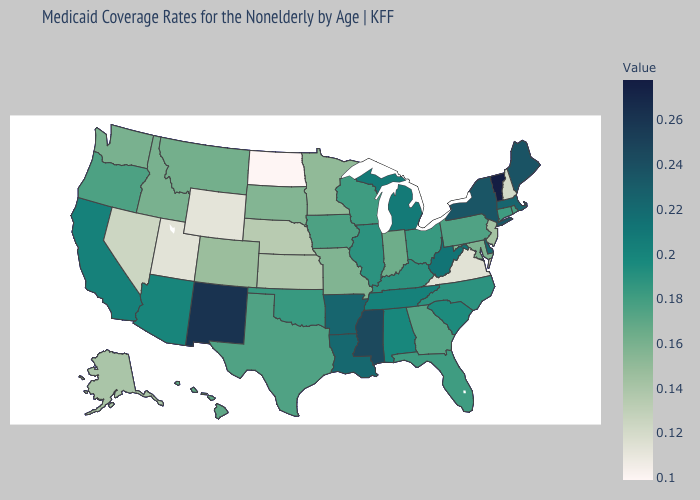Does North Dakota have the lowest value in the USA?
Be succinct. Yes. Does Wisconsin have a higher value than Wyoming?
Give a very brief answer. Yes. Does North Dakota have the lowest value in the USA?
Quick response, please. Yes. Does Iowa have the highest value in the MidWest?
Keep it brief. No. Does Alabama have a higher value than New Mexico?
Answer briefly. No. Among the states that border Michigan , does Ohio have the highest value?
Concise answer only. Yes. Which states hav the highest value in the Northeast?
Give a very brief answer. Vermont. Is the legend a continuous bar?
Answer briefly. Yes. 